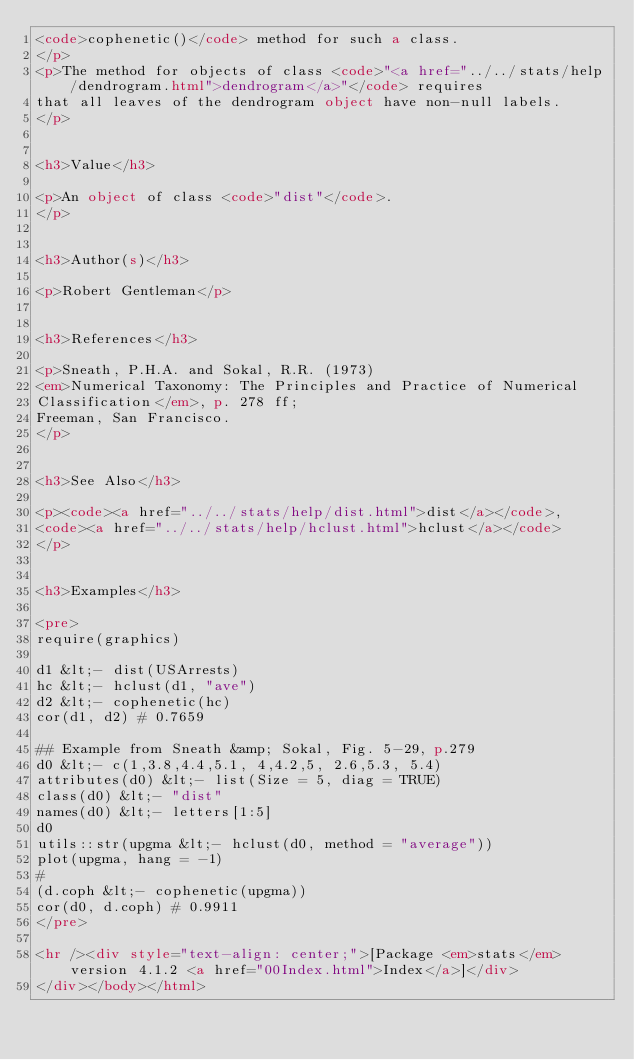<code> <loc_0><loc_0><loc_500><loc_500><_HTML_><code>cophenetic()</code> method for such a class.
</p>
<p>The method for objects of class <code>"<a href="../../stats/help/dendrogram.html">dendrogram</a>"</code> requires
that all leaves of the dendrogram object have non-null labels.
</p>


<h3>Value</h3>

<p>An object of class <code>"dist"</code>.
</p>


<h3>Author(s)</h3>

<p>Robert Gentleman</p>


<h3>References</h3>

<p>Sneath, P.H.A. and Sokal, R.R. (1973)
<em>Numerical Taxonomy: The Principles and Practice of Numerical
Classification</em>, p. 278 ff;
Freeman, San Francisco.
</p>


<h3>See Also</h3>

<p><code><a href="../../stats/help/dist.html">dist</a></code>,
<code><a href="../../stats/help/hclust.html">hclust</a></code>
</p>


<h3>Examples</h3>

<pre>
require(graphics)

d1 &lt;- dist(USArrests)
hc &lt;- hclust(d1, "ave")
d2 &lt;- cophenetic(hc)
cor(d1, d2) # 0.7659

## Example from Sneath &amp; Sokal, Fig. 5-29, p.279
d0 &lt;- c(1,3.8,4.4,5.1, 4,4.2,5, 2.6,5.3, 5.4)
attributes(d0) &lt;- list(Size = 5, diag = TRUE)
class(d0) &lt;- "dist"
names(d0) &lt;- letters[1:5]
d0
utils::str(upgma &lt;- hclust(d0, method = "average"))
plot(upgma, hang = -1)
#
(d.coph &lt;- cophenetic(upgma))
cor(d0, d.coph) # 0.9911
</pre>

<hr /><div style="text-align: center;">[Package <em>stats</em> version 4.1.2 <a href="00Index.html">Index</a>]</div>
</div></body></html>
</code> 